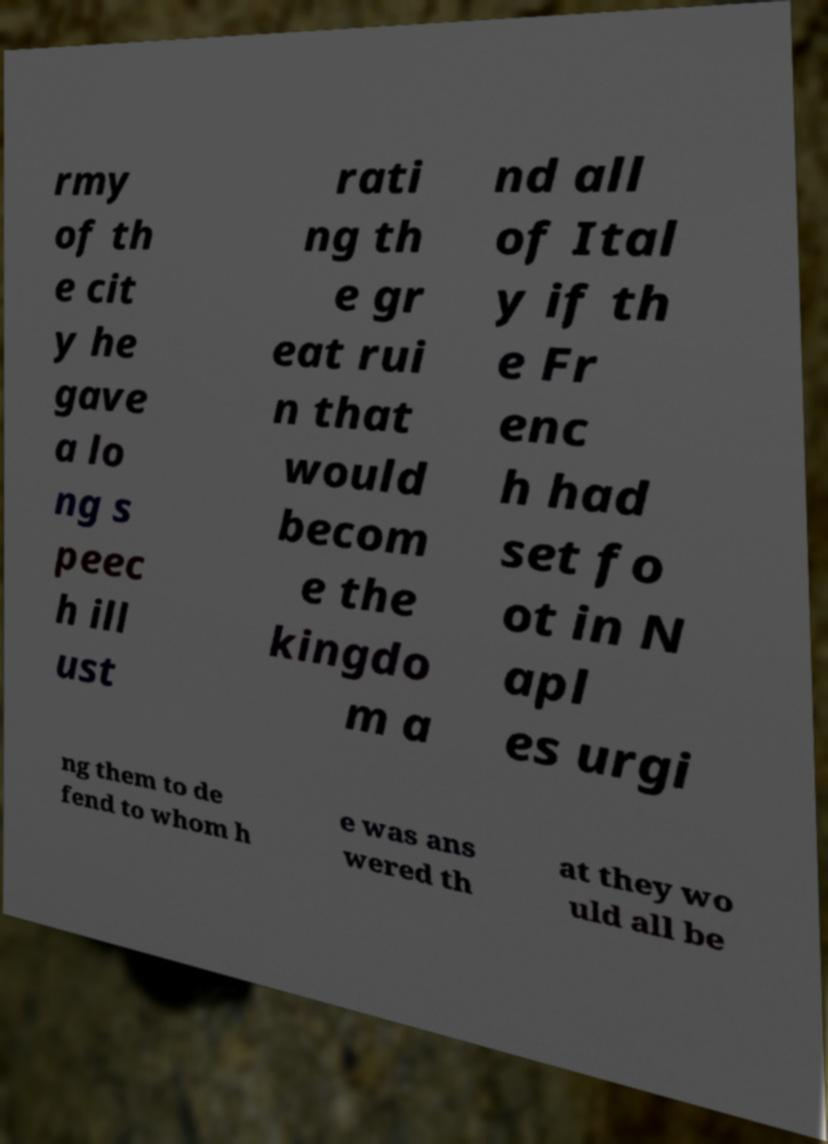There's text embedded in this image that I need extracted. Can you transcribe it verbatim? rmy of th e cit y he gave a lo ng s peec h ill ust rati ng th e gr eat rui n that would becom e the kingdo m a nd all of Ital y if th e Fr enc h had set fo ot in N apl es urgi ng them to de fend to whom h e was ans wered th at they wo uld all be 